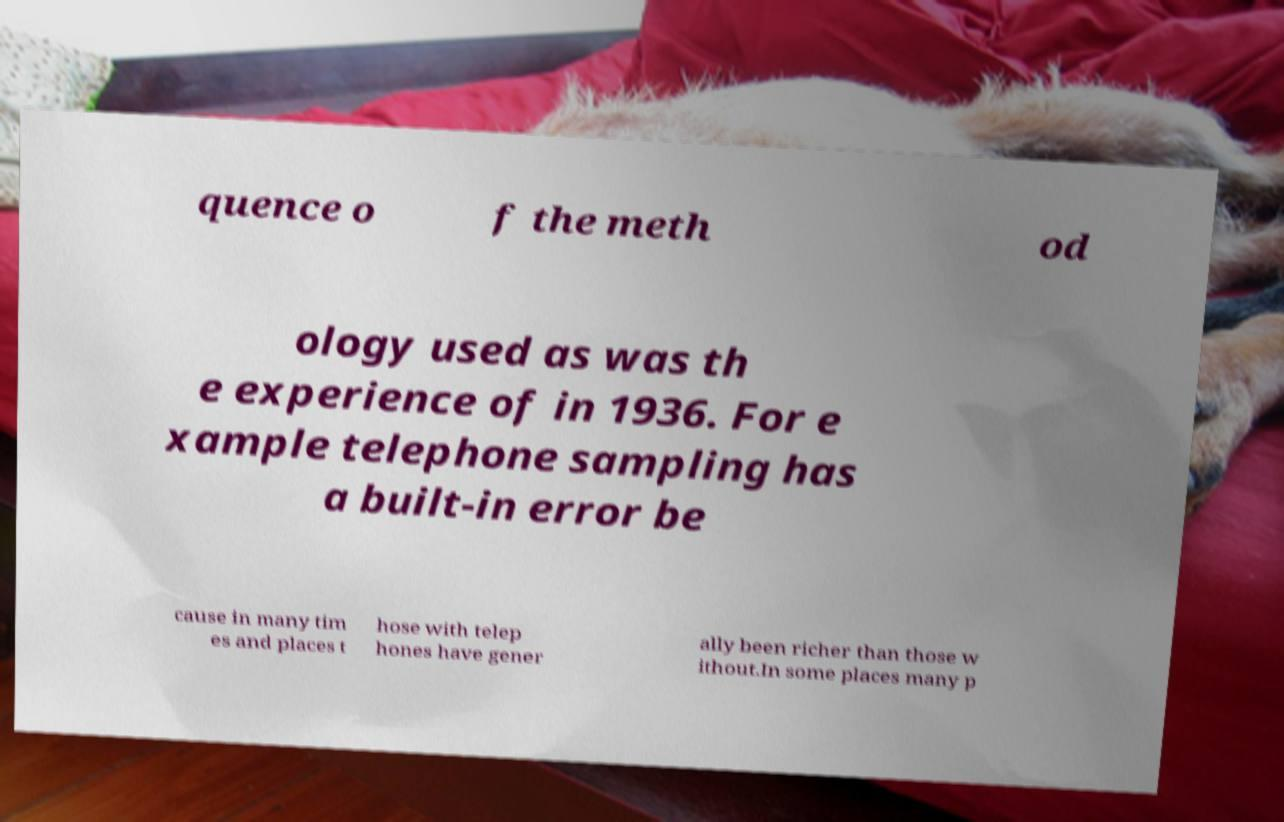There's text embedded in this image that I need extracted. Can you transcribe it verbatim? quence o f the meth od ology used as was th e experience of in 1936. For e xample telephone sampling has a built-in error be cause in many tim es and places t hose with telep hones have gener ally been richer than those w ithout.In some places many p 